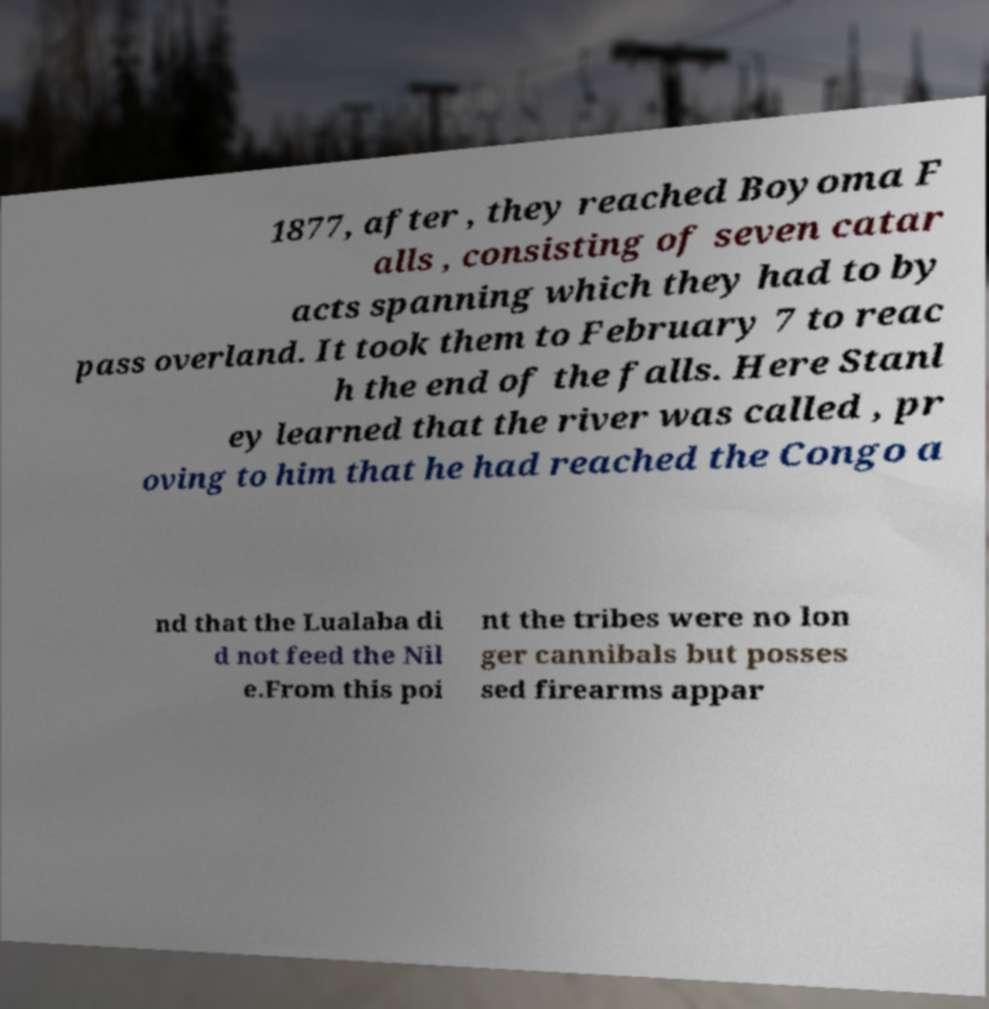I need the written content from this picture converted into text. Can you do that? 1877, after , they reached Boyoma F alls , consisting of seven catar acts spanning which they had to by pass overland. It took them to February 7 to reac h the end of the falls. Here Stanl ey learned that the river was called , pr oving to him that he had reached the Congo a nd that the Lualaba di d not feed the Nil e.From this poi nt the tribes were no lon ger cannibals but posses sed firearms appar 